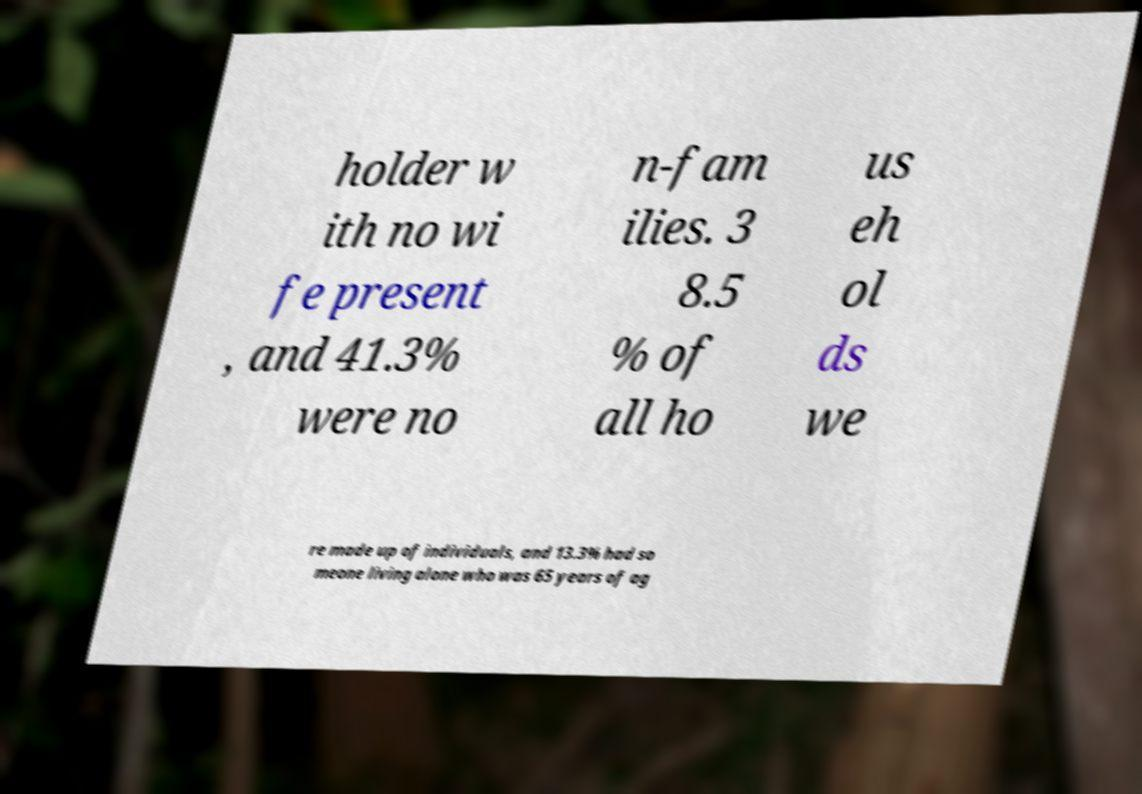Could you assist in decoding the text presented in this image and type it out clearly? holder w ith no wi fe present , and 41.3% were no n-fam ilies. 3 8.5 % of all ho us eh ol ds we re made up of individuals, and 13.3% had so meone living alone who was 65 years of ag 